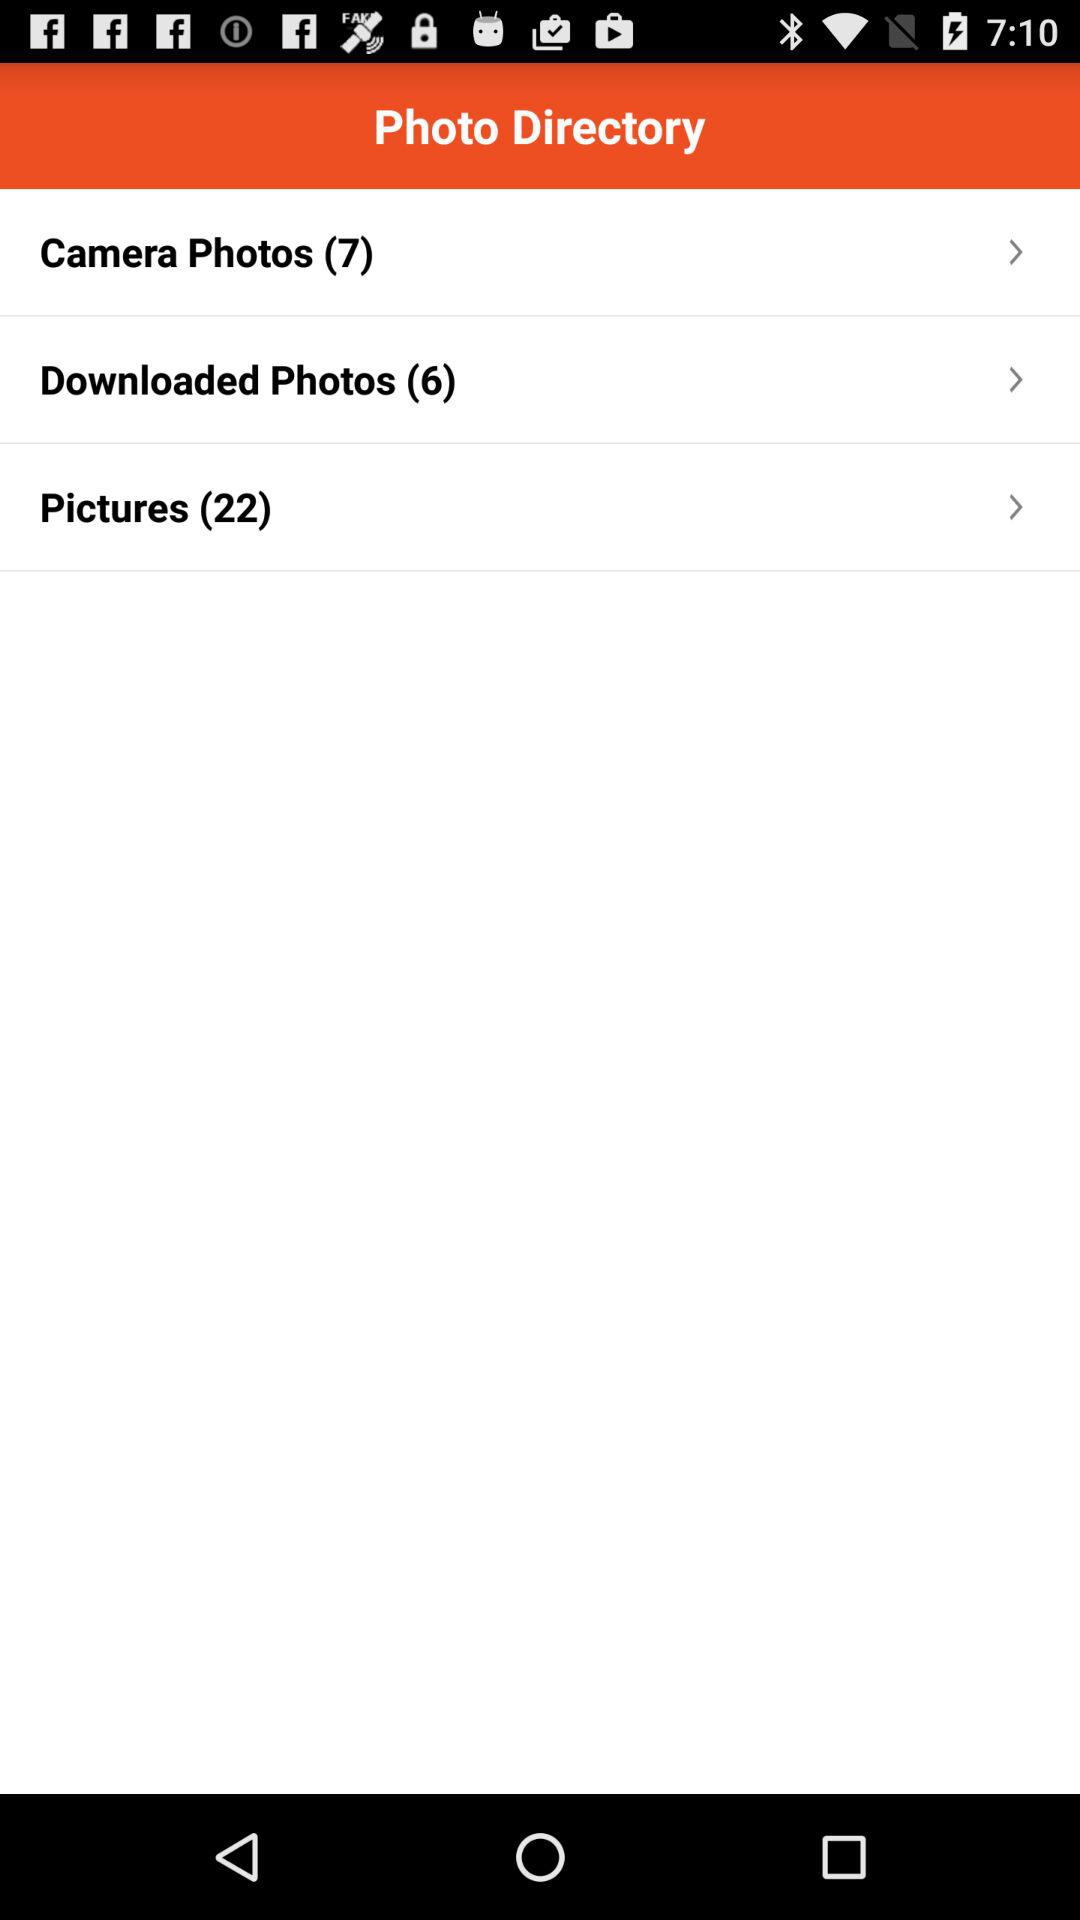How many photos are in all of the folders combined?
Answer the question using a single word or phrase. 35 